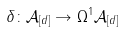Convert formula to latex. <formula><loc_0><loc_0><loc_500><loc_500>\delta \colon \mathcal { A } _ { [ d ] } \rightarrow \Omega ^ { 1 } \mathcal { A } _ { [ d ] }</formula> 